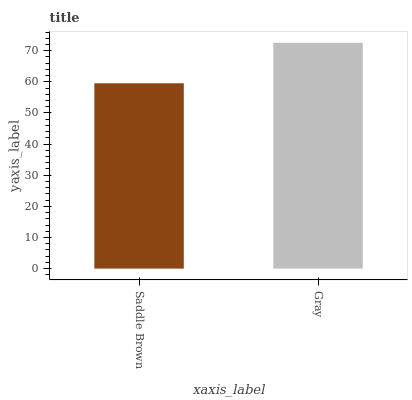Is Saddle Brown the minimum?
Answer yes or no. Yes. Is Gray the maximum?
Answer yes or no. Yes. Is Gray the minimum?
Answer yes or no. No. Is Gray greater than Saddle Brown?
Answer yes or no. Yes. Is Saddle Brown less than Gray?
Answer yes or no. Yes. Is Saddle Brown greater than Gray?
Answer yes or no. No. Is Gray less than Saddle Brown?
Answer yes or no. No. Is Gray the high median?
Answer yes or no. Yes. Is Saddle Brown the low median?
Answer yes or no. Yes. Is Saddle Brown the high median?
Answer yes or no. No. Is Gray the low median?
Answer yes or no. No. 